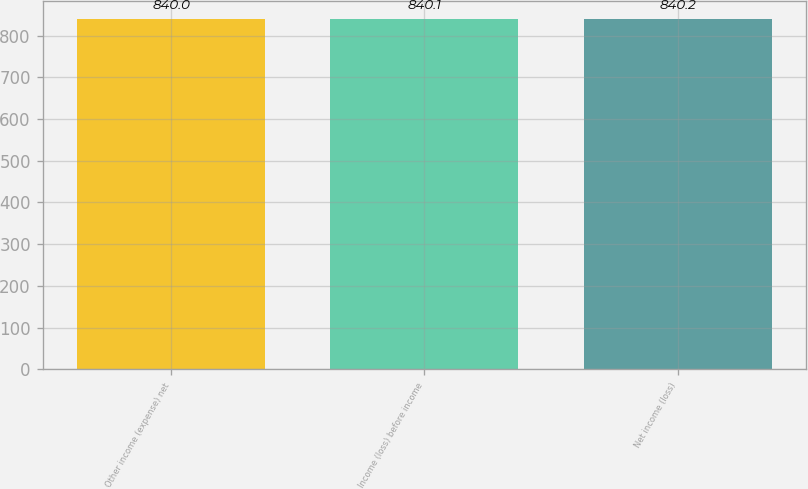<chart> <loc_0><loc_0><loc_500><loc_500><bar_chart><fcel>Other income (expense) net<fcel>Income (loss) before income<fcel>Net income (loss)<nl><fcel>840<fcel>840.1<fcel>840.2<nl></chart> 